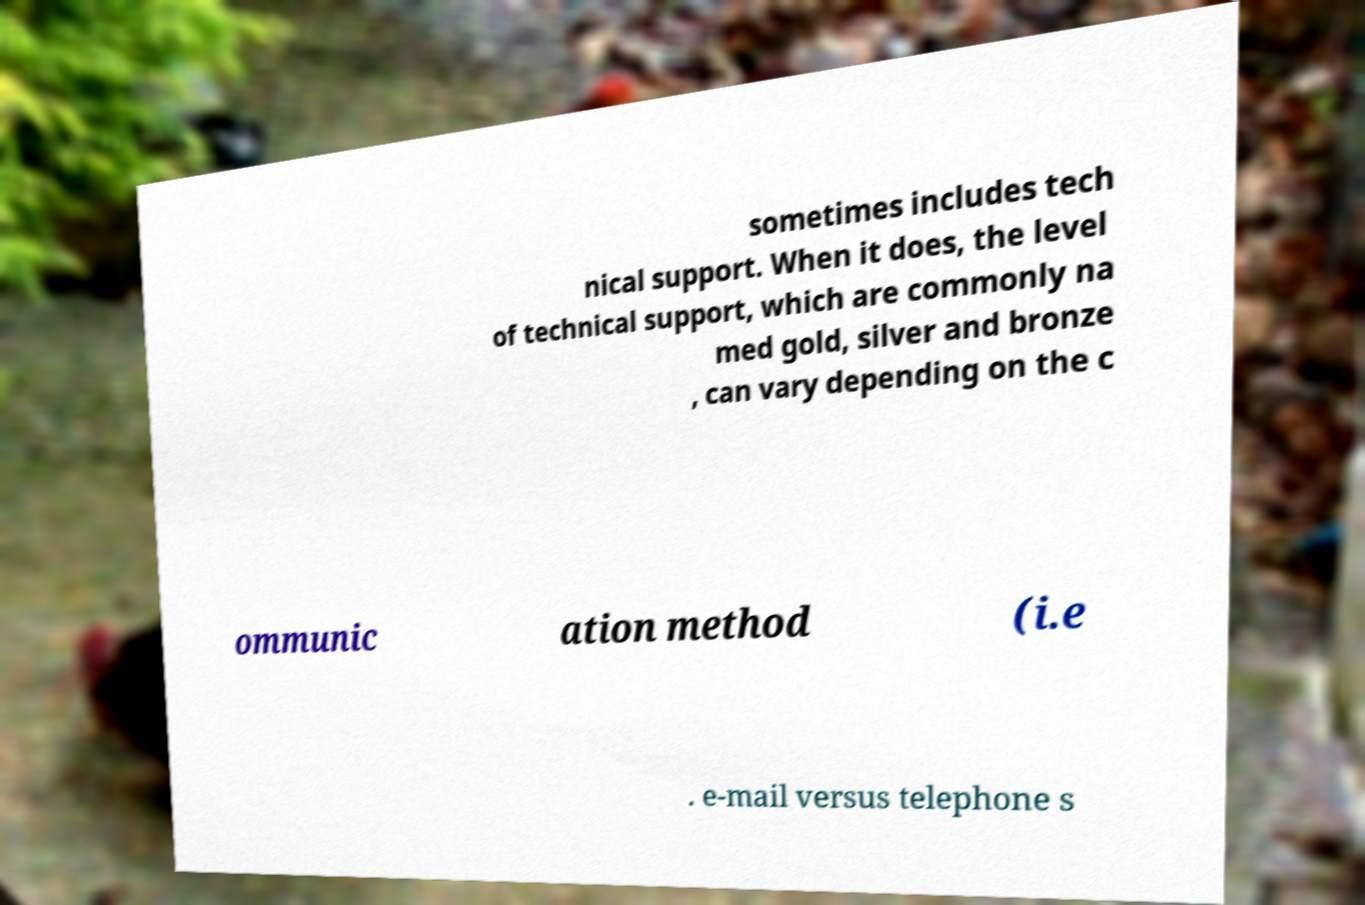Could you assist in decoding the text presented in this image and type it out clearly? sometimes includes tech nical support. When it does, the level of technical support, which are commonly na med gold, silver and bronze , can vary depending on the c ommunic ation method (i.e . e-mail versus telephone s 